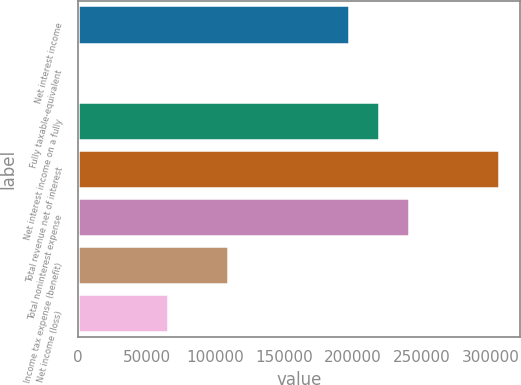<chart> <loc_0><loc_0><loc_500><loc_500><bar_chart><fcel>Net interest income<fcel>Fully taxable-equivalent<fcel>Net interest income on a fully<fcel>Total revenue net of interest<fcel>Total noninterest expense<fcel>Income tax expense (benefit)<fcel>Net income (loss)<nl><fcel>196882<fcel>270<fcel>218728<fcel>306111<fcel>240574<fcel>109499<fcel>65807.4<nl></chart> 